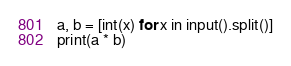<code> <loc_0><loc_0><loc_500><loc_500><_Python_>a, b = [int(x) for x in input().split()]
print(a * b)</code> 